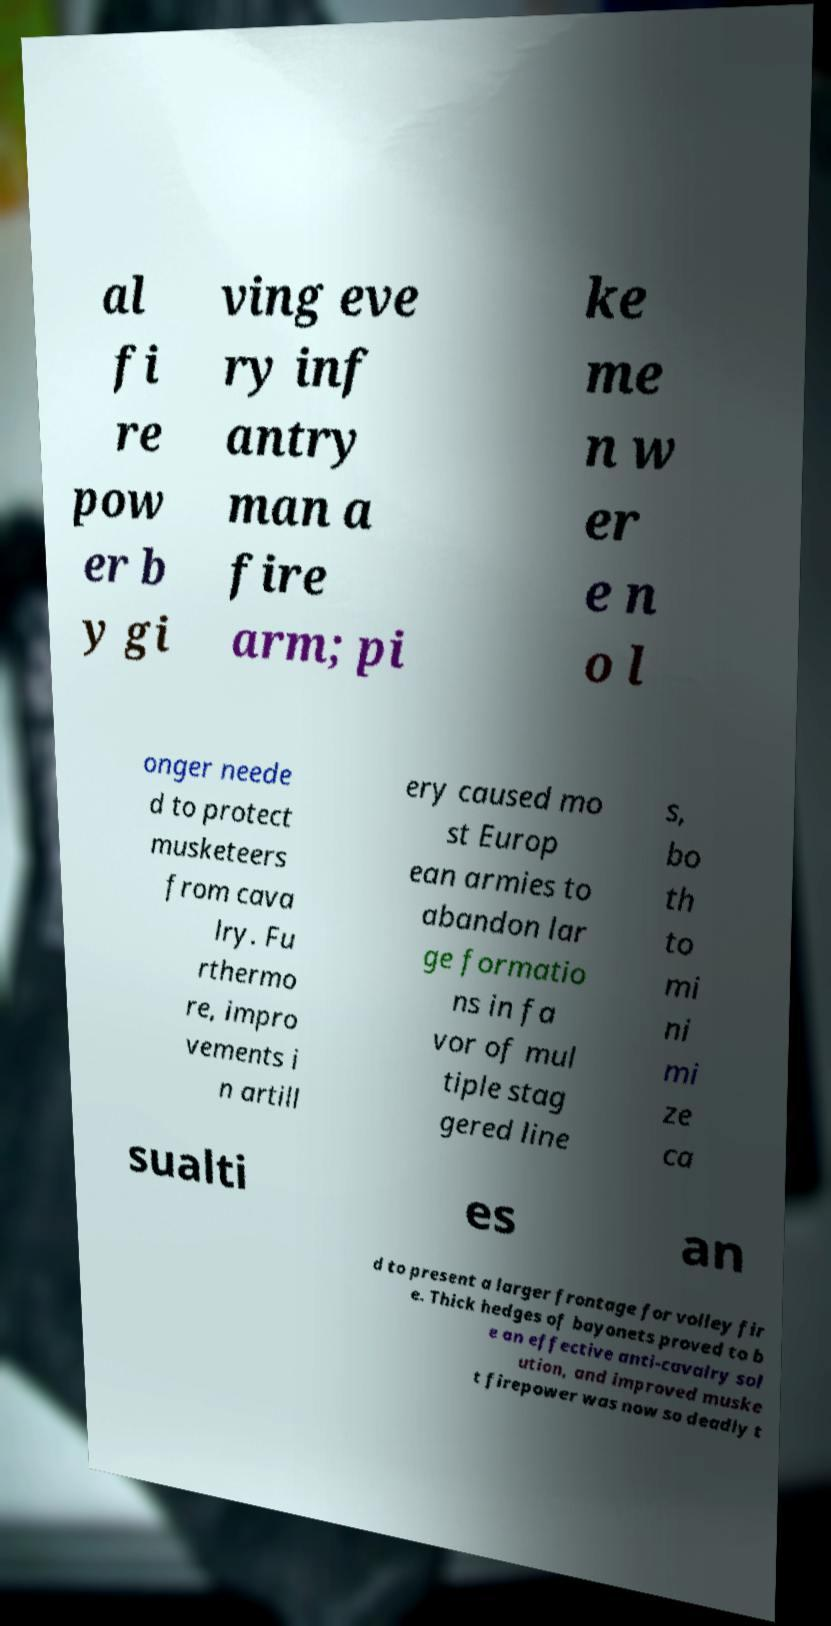Please read and relay the text visible in this image. What does it say? al fi re pow er b y gi ving eve ry inf antry man a fire arm; pi ke me n w er e n o l onger neede d to protect musketeers from cava lry. Fu rthermo re, impro vements i n artill ery caused mo st Europ ean armies to abandon lar ge formatio ns in fa vor of mul tiple stag gered line s, bo th to mi ni mi ze ca sualti es an d to present a larger frontage for volley fir e. Thick hedges of bayonets proved to b e an effective anti-cavalry sol ution, and improved muske t firepower was now so deadly t 